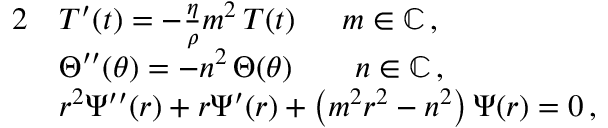<formula> <loc_0><loc_0><loc_500><loc_500>\begin{array} { r l } { 2 } & { T ^ { \prime } ( t ) = - \frac { \eta } { \rho } m ^ { 2 } \, T ( t ) \quad \, m \in \mathbb { C } \, , } \\ & { \Theta ^ { \prime \prime } ( \theta ) = - n ^ { 2 } \, \Theta ( \theta ) \quad n \in \mathbb { C } \, , } \\ & { r ^ { 2 } \Psi ^ { \prime \prime } ( r ) + r \Psi ^ { \prime } ( r ) + \left ( m ^ { 2 } r ^ { 2 } - n ^ { 2 } \right ) \Psi ( r ) = 0 \, , } \end{array}</formula> 